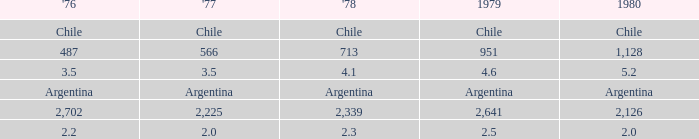What is 1980 when 1978 is 2.3? 2.0. 